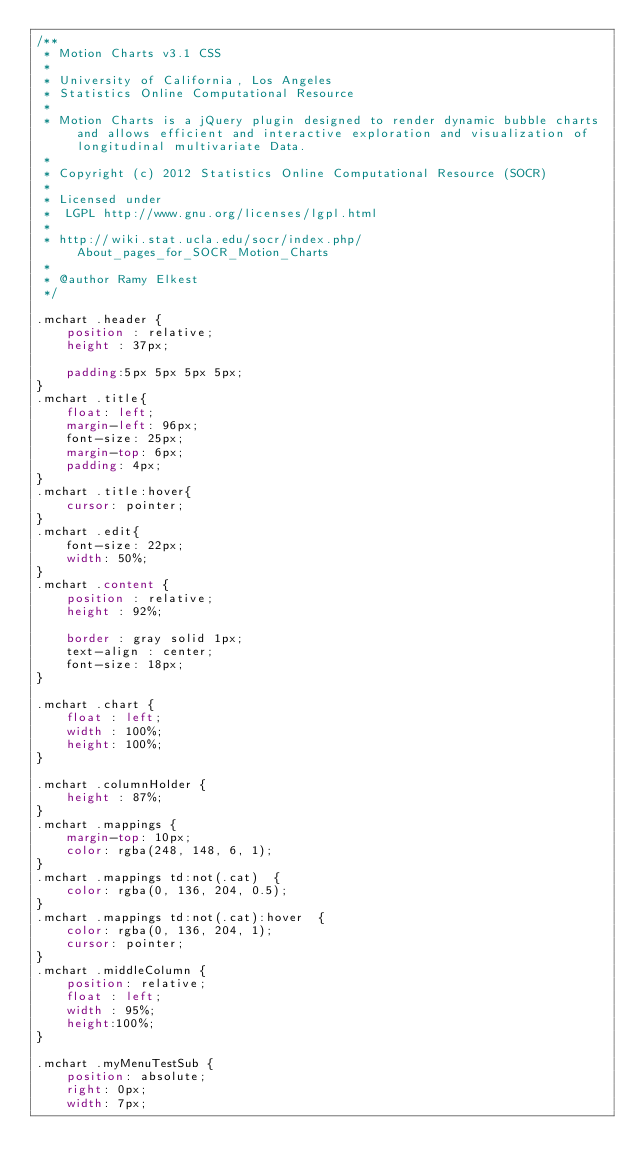<code> <loc_0><loc_0><loc_500><loc_500><_CSS_>/**
 * Motion Charts v3.1 CSS
 *
 * University of California, Los Angeles
 * Statistics Online Computational Resource
 * 
 * Motion Charts is a jQuery plugin designed to render dynamic bubble charts and allows efficient and interactive exploration and visualization of longitudinal multivariate Data.
 *
 * Copyright (c) 2012 Statistics Online Computational Resource (SOCR)
 *
 * Licensed under
 *	LGPL http://www.gnu.org/licenses/lgpl.html
 *
 * http://wiki.stat.ucla.edu/socr/index.php/About_pages_for_SOCR_Motion_Charts
 *
 * @author Ramy Elkest
 */

.mchart .header {
	position : relative;
	height : 37px;
	
	padding:5px 5px 5px 5px;
}
.mchart .title{
	float: left;
	margin-left: 96px;
	font-size: 25px;
	margin-top: 6px;
	padding: 4px;
}
.mchart .title:hover{
	cursor: pointer;
}
.mchart .edit{
	font-size: 22px;
	width: 50%;
}
.mchart .content {
	position : relative;
	height : 92%;
	
	border : gray solid 1px;	
	text-align : center;
	font-size: 18px;
}

.mchart .chart {
	float : left;
	width : 100%;
	height: 100%;
}

.mchart .columnHolder {
	height : 87%;
}
.mchart .mappings {
	margin-top: 10px;	
	color: rgba(248, 148, 6, 1);
}
.mchart .mappings td:not(.cat)  {
	color: rgba(0, 136, 204, 0.5); 
}
.mchart .mappings td:not(.cat):hover  {
	color: rgba(0, 136, 204, 1); 
	cursor: pointer;
}
.mchart .middleColumn {
	position: relative;
	float : left;
	width : 95%;
	height:100%;
}

.mchart .myMenuTestSub {
	position: absolute;
	right: 0px;
	width: 7px;</code> 